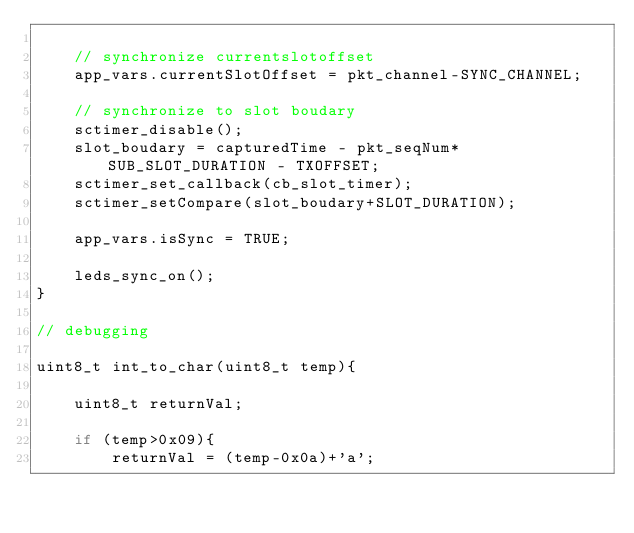Convert code to text. <code><loc_0><loc_0><loc_500><loc_500><_C_>
    // synchronize currentslotoffset
    app_vars.currentSlotOffset = pkt_channel-SYNC_CHANNEL;

    // synchronize to slot boudary
    sctimer_disable();
    slot_boudary = capturedTime - pkt_seqNum*SUB_SLOT_DURATION - TXOFFSET;
    sctimer_set_callback(cb_slot_timer);
    sctimer_setCompare(slot_boudary+SLOT_DURATION);

    app_vars.isSync = TRUE;

    leds_sync_on();
}

// debugging

uint8_t int_to_char(uint8_t temp){

    uint8_t returnVal;

    if (temp>0x09){
        returnVal = (temp-0x0a)+'a';</code> 